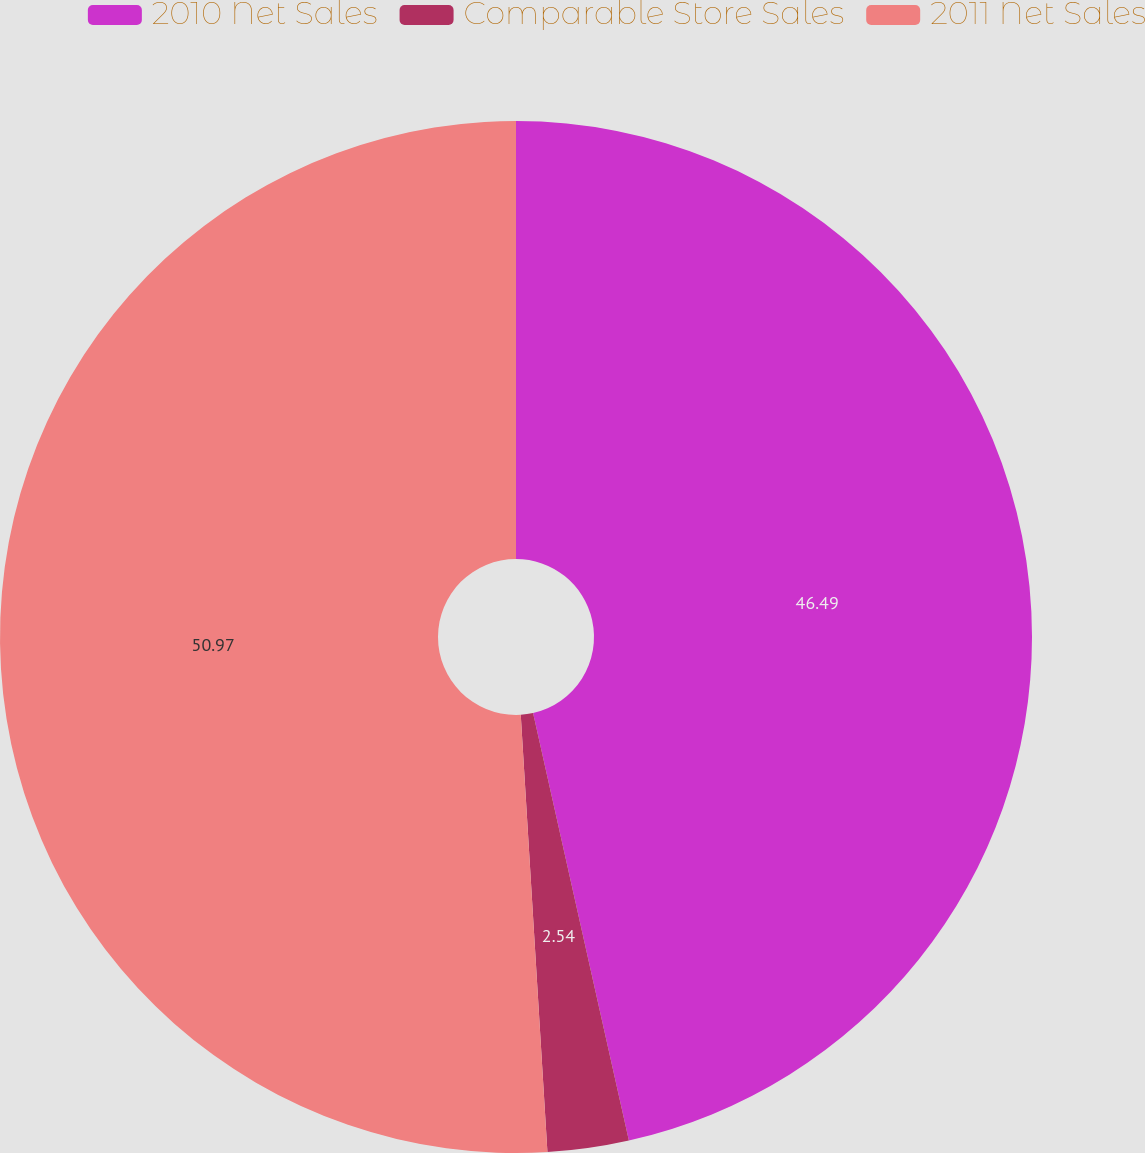Convert chart to OTSL. <chart><loc_0><loc_0><loc_500><loc_500><pie_chart><fcel>2010 Net Sales<fcel>Comparable Store Sales<fcel>2011 Net Sales<nl><fcel>46.49%<fcel>2.54%<fcel>50.97%<nl></chart> 